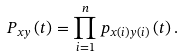<formula> <loc_0><loc_0><loc_500><loc_500>P _ { x y } \left ( t \right ) = \prod _ { i = 1 } ^ { n } p _ { x \left ( i \right ) y \left ( i \right ) } \left ( t \right ) .</formula> 